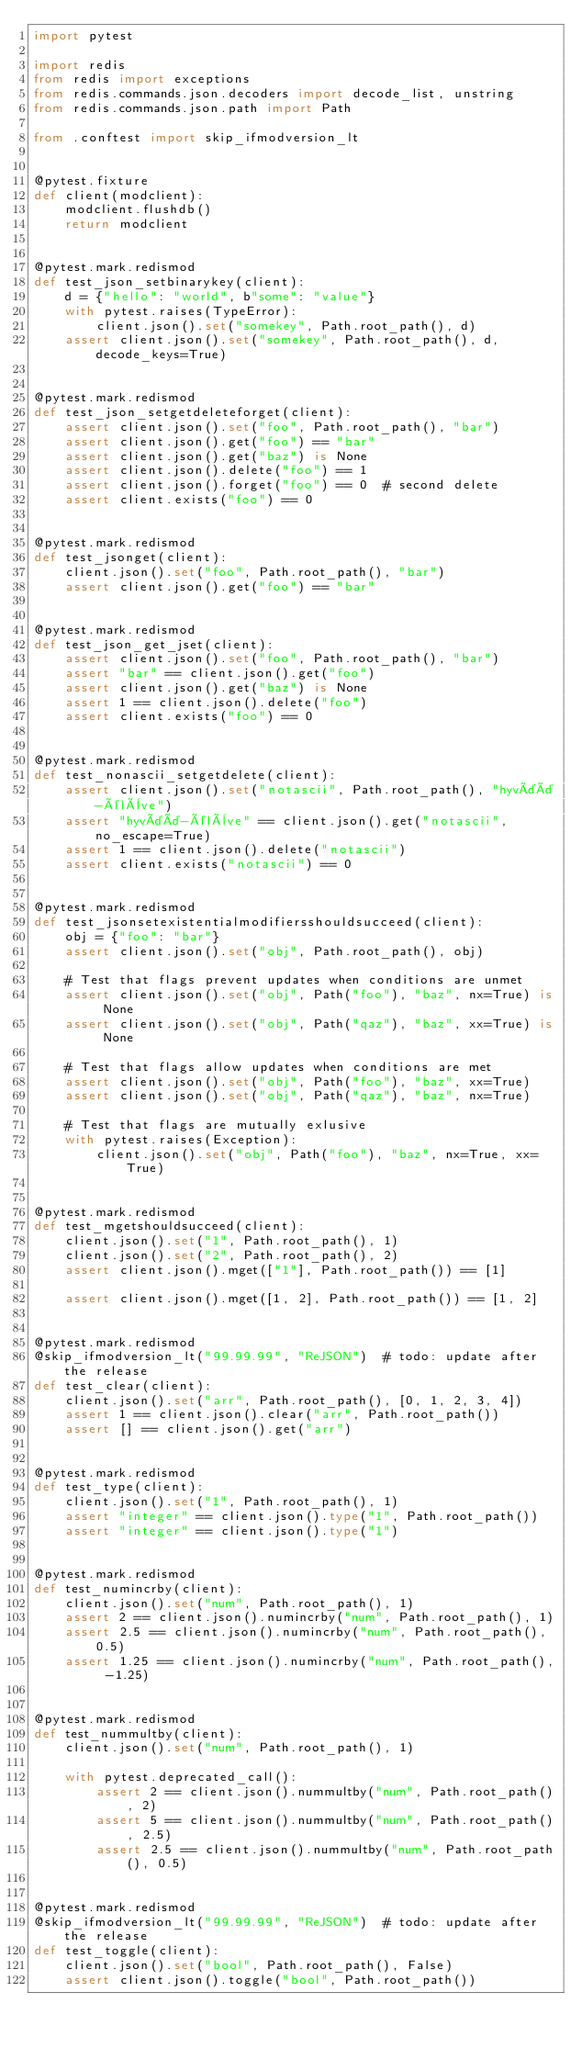Convert code to text. <code><loc_0><loc_0><loc_500><loc_500><_Python_>import pytest

import redis
from redis import exceptions
from redis.commands.json.decoders import decode_list, unstring
from redis.commands.json.path import Path

from .conftest import skip_ifmodversion_lt


@pytest.fixture
def client(modclient):
    modclient.flushdb()
    return modclient


@pytest.mark.redismod
def test_json_setbinarykey(client):
    d = {"hello": "world", b"some": "value"}
    with pytest.raises(TypeError):
        client.json().set("somekey", Path.root_path(), d)
    assert client.json().set("somekey", Path.root_path(), d, decode_keys=True)


@pytest.mark.redismod
def test_json_setgetdeleteforget(client):
    assert client.json().set("foo", Path.root_path(), "bar")
    assert client.json().get("foo") == "bar"
    assert client.json().get("baz") is None
    assert client.json().delete("foo") == 1
    assert client.json().forget("foo") == 0  # second delete
    assert client.exists("foo") == 0


@pytest.mark.redismod
def test_jsonget(client):
    client.json().set("foo", Path.root_path(), "bar")
    assert client.json().get("foo") == "bar"


@pytest.mark.redismod
def test_json_get_jset(client):
    assert client.json().set("foo", Path.root_path(), "bar")
    assert "bar" == client.json().get("foo")
    assert client.json().get("baz") is None
    assert 1 == client.json().delete("foo")
    assert client.exists("foo") == 0


@pytest.mark.redismod
def test_nonascii_setgetdelete(client):
    assert client.json().set("notascii", Path.root_path(), "hyvää-élève")
    assert "hyvää-élève" == client.json().get("notascii", no_escape=True)
    assert 1 == client.json().delete("notascii")
    assert client.exists("notascii") == 0


@pytest.mark.redismod
def test_jsonsetexistentialmodifiersshouldsucceed(client):
    obj = {"foo": "bar"}
    assert client.json().set("obj", Path.root_path(), obj)

    # Test that flags prevent updates when conditions are unmet
    assert client.json().set("obj", Path("foo"), "baz", nx=True) is None
    assert client.json().set("obj", Path("qaz"), "baz", xx=True) is None

    # Test that flags allow updates when conditions are met
    assert client.json().set("obj", Path("foo"), "baz", xx=True)
    assert client.json().set("obj", Path("qaz"), "baz", nx=True)

    # Test that flags are mutually exlusive
    with pytest.raises(Exception):
        client.json().set("obj", Path("foo"), "baz", nx=True, xx=True)


@pytest.mark.redismod
def test_mgetshouldsucceed(client):
    client.json().set("1", Path.root_path(), 1)
    client.json().set("2", Path.root_path(), 2)
    assert client.json().mget(["1"], Path.root_path()) == [1]

    assert client.json().mget([1, 2], Path.root_path()) == [1, 2]


@pytest.mark.redismod
@skip_ifmodversion_lt("99.99.99", "ReJSON")  # todo: update after the release
def test_clear(client):
    client.json().set("arr", Path.root_path(), [0, 1, 2, 3, 4])
    assert 1 == client.json().clear("arr", Path.root_path())
    assert [] == client.json().get("arr")


@pytest.mark.redismod
def test_type(client):
    client.json().set("1", Path.root_path(), 1)
    assert "integer" == client.json().type("1", Path.root_path())
    assert "integer" == client.json().type("1")


@pytest.mark.redismod
def test_numincrby(client):
    client.json().set("num", Path.root_path(), 1)
    assert 2 == client.json().numincrby("num", Path.root_path(), 1)
    assert 2.5 == client.json().numincrby("num", Path.root_path(), 0.5)
    assert 1.25 == client.json().numincrby("num", Path.root_path(), -1.25)


@pytest.mark.redismod
def test_nummultby(client):
    client.json().set("num", Path.root_path(), 1)

    with pytest.deprecated_call():
        assert 2 == client.json().nummultby("num", Path.root_path(), 2)
        assert 5 == client.json().nummultby("num", Path.root_path(), 2.5)
        assert 2.5 == client.json().nummultby("num", Path.root_path(), 0.5)


@pytest.mark.redismod
@skip_ifmodversion_lt("99.99.99", "ReJSON")  # todo: update after the release
def test_toggle(client):
    client.json().set("bool", Path.root_path(), False)
    assert client.json().toggle("bool", Path.root_path())</code> 